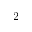<formula> <loc_0><loc_0><loc_500><loc_500>2</formula> 